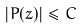<formula> <loc_0><loc_0><loc_500><loc_500>| P ( z ) | \leq C</formula> 